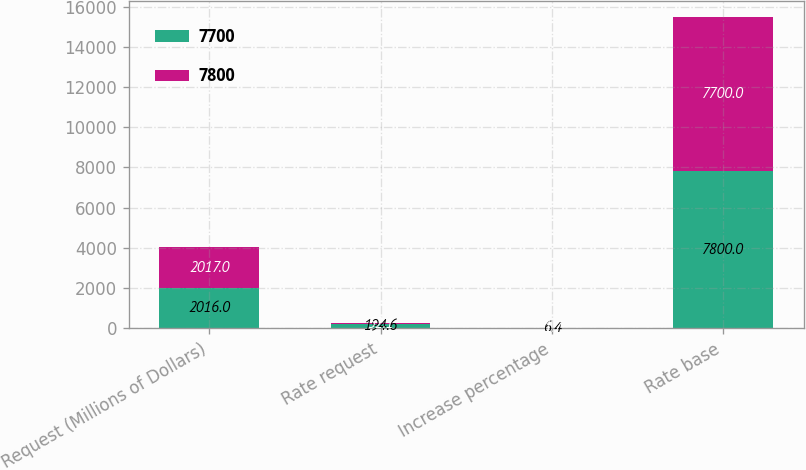Convert chart to OTSL. <chart><loc_0><loc_0><loc_500><loc_500><stacked_bar_chart><ecel><fcel>Request (Millions of Dollars)<fcel>Rate request<fcel>Increase percentage<fcel>Rate base<nl><fcel>7700<fcel>2016<fcel>194.6<fcel>6.4<fcel>7800<nl><fcel>7800<fcel>2017<fcel>52.1<fcel>1.7<fcel>7700<nl></chart> 